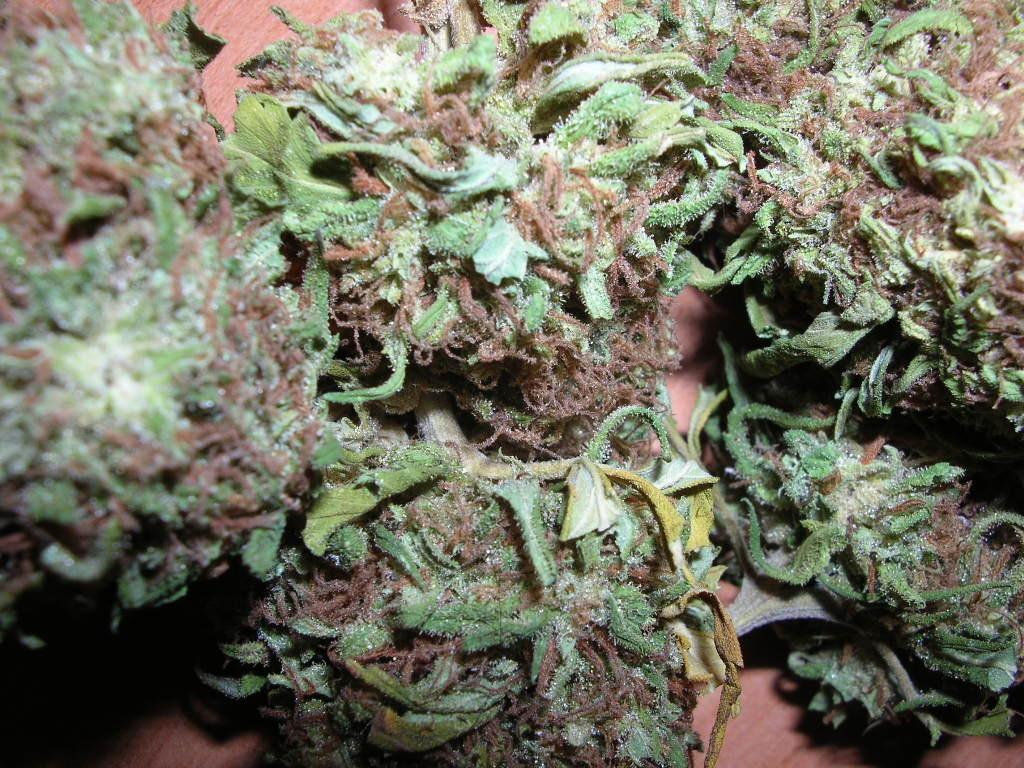Can you describe this image briefly? In this picture, we see dirty harry strain placed on the brown color table. 